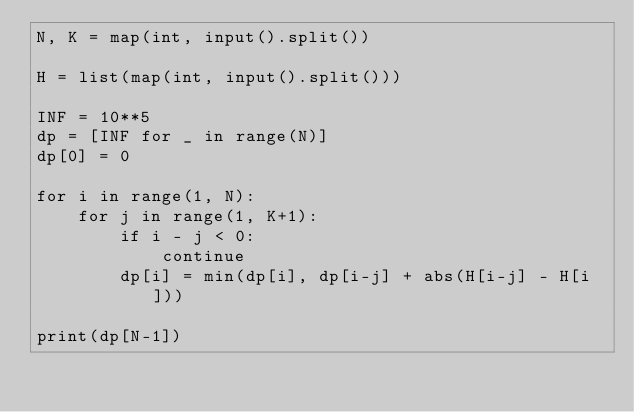<code> <loc_0><loc_0><loc_500><loc_500><_Python_>N, K = map(int, input().split())

H = list(map(int, input().split()))

INF = 10**5
dp = [INF for _ in range(N)]
dp[0] = 0

for i in range(1, N):
    for j in range(1, K+1):
        if i - j < 0:
            continue
        dp[i] = min(dp[i], dp[i-j] + abs(H[i-j] - H[i]))

print(dp[N-1])</code> 